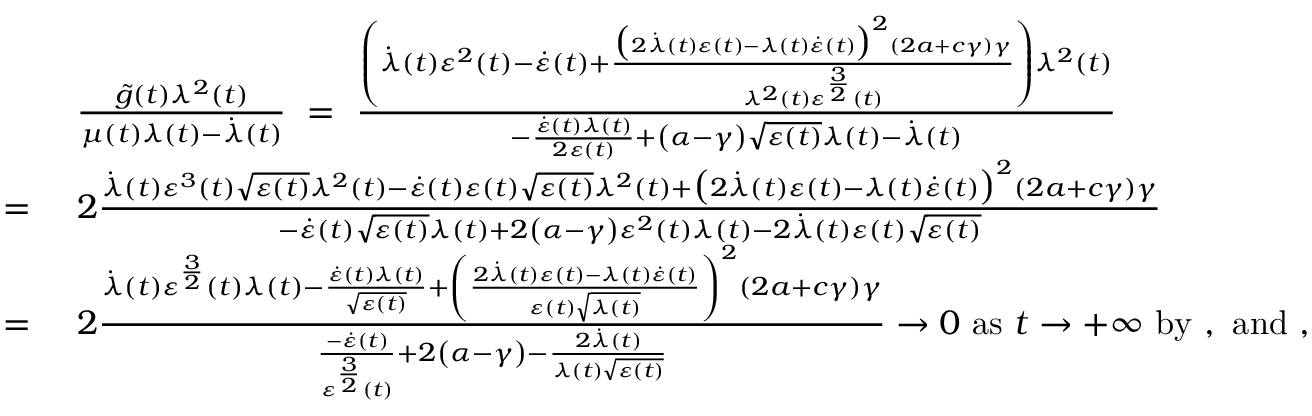<formula> <loc_0><loc_0><loc_500><loc_500>\begin{array} { r l } & { \frac { \tilde { g } ( t ) \lambda ^ { 2 } ( t ) } { \mu ( t ) \lambda ( t ) - \dot { \lambda } ( t ) } \ = \ \frac { \left ( \dot { \lambda } ( t ) \varepsilon ^ { 2 } ( t ) - \dot { \varepsilon } ( t ) + \frac { \left ( 2 \dot { \lambda } ( t ) \varepsilon ( t ) - \lambda ( t ) \dot { \varepsilon } ( t ) \right ) ^ { 2 } ( 2 a + c \gamma ) \gamma } { \lambda ^ { 2 } ( t ) \varepsilon ^ { \frac { 3 } { 2 } } ( t ) } \right ) \lambda ^ { 2 } ( t ) } { - \frac { \dot { \varepsilon } ( t ) \lambda ( t ) } { 2 \varepsilon ( t ) } + \left ( \alpha - \gamma \right ) \sqrt { \varepsilon ( t ) } \lambda ( t ) - \dot { \lambda } ( t ) } } \\ { = \ } & { 2 \frac { \dot { \lambda } ( t ) \varepsilon ^ { 3 } ( t ) \sqrt { \varepsilon ( t ) } \lambda ^ { 2 } ( t ) - \dot { \varepsilon } ( t ) \varepsilon ( t ) \sqrt { \varepsilon ( t ) } \lambda ^ { 2 } ( t ) + \left ( 2 \dot { \lambda } ( t ) \varepsilon ( t ) - \lambda ( t ) \dot { \varepsilon } ( t ) \right ) ^ { 2 } ( 2 a + c \gamma ) \gamma } { - \dot { \varepsilon } ( t ) \sqrt { \varepsilon ( t ) } \lambda ( t ) + 2 \left ( \alpha - \gamma \right ) \varepsilon ^ { 2 } ( t ) \lambda ( t ) - 2 \dot { \lambda } ( t ) \varepsilon ( t ) \sqrt { \varepsilon ( t ) } } } \\ { = \ } & { 2 \frac { \dot { \lambda } ( t ) \varepsilon ^ { \frac { 3 } { 2 } } ( t ) \lambda ( t ) - \frac { \dot { \varepsilon } ( t ) \lambda ( t ) } { \sqrt { \varepsilon ( t ) } } + \left ( \frac { 2 \dot { \lambda } ( t ) \varepsilon ( t ) - \lambda ( t ) \dot { \varepsilon } ( t ) } { \varepsilon ( t ) \sqrt { \lambda ( t ) } } \right ) ^ { 2 } ( 2 a + c \gamma ) \gamma } { \frac { - \dot { \varepsilon } ( t ) } { \varepsilon ^ { \frac { 3 } { 2 } } ( t ) } + 2 \left ( \alpha - \gamma \right ) - \frac { 2 \dot { \lambda } ( t ) } { \lambda ( t ) \sqrt { \varepsilon ( t ) } } } \to 0 a s t \to + \infty b y , a n d , } \end{array}</formula> 